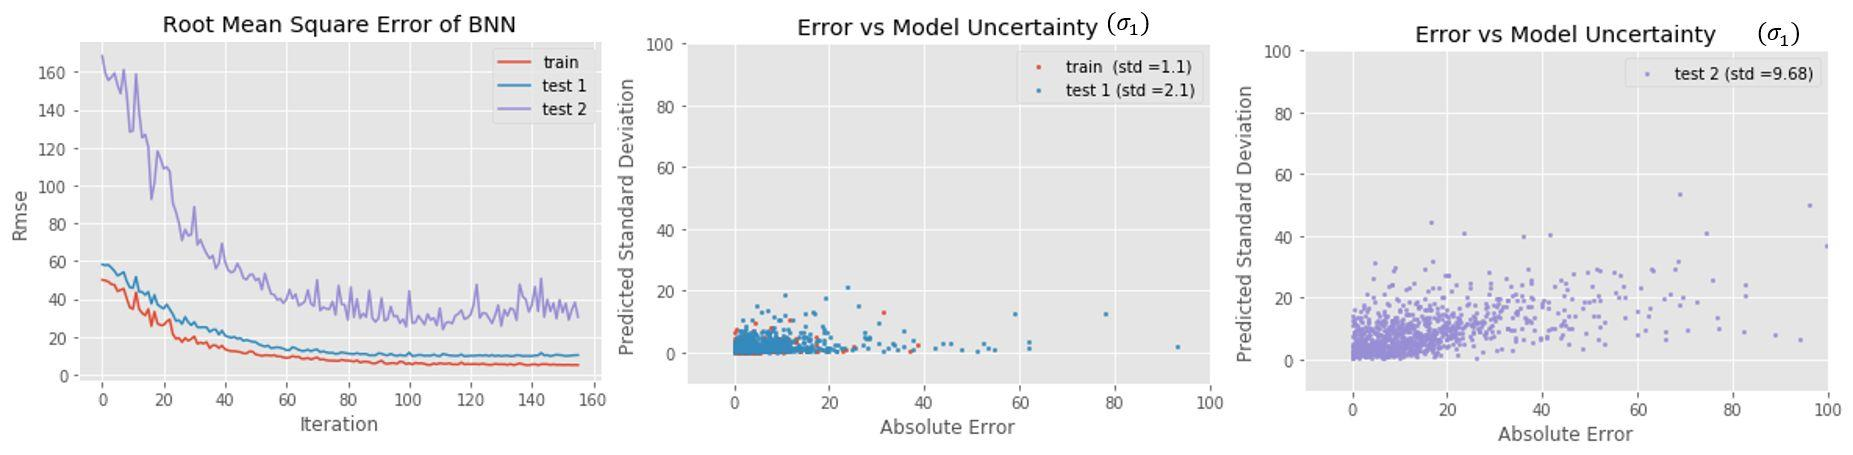What might be the reason 'test 2' shows such high model uncertainty? The elevated model uncertainty in 'test 2' could be resulting from various factors. It's possible that the underlying data for 'test 2' is more volatile or contains more outliers, the model might be less well-suited or poorly calibrated for the data, or it could be that 'test 2' represents a more complex scenario where the predictive features have a weaker correlation with the target variable. 